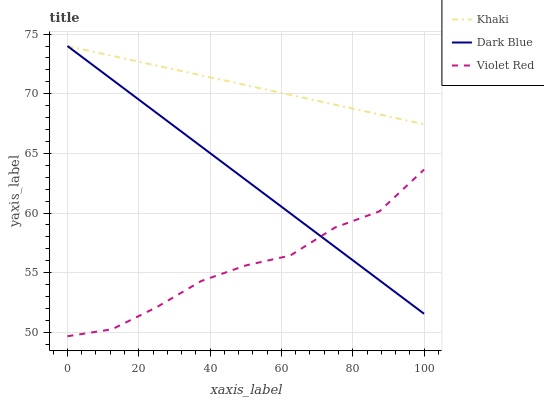Does Violet Red have the minimum area under the curve?
Answer yes or no. Yes. Does Khaki have the maximum area under the curve?
Answer yes or no. Yes. Does Khaki have the minimum area under the curve?
Answer yes or no. No. Does Violet Red have the maximum area under the curve?
Answer yes or no. No. Is Dark Blue the smoothest?
Answer yes or no. Yes. Is Violet Red the roughest?
Answer yes or no. Yes. Is Khaki the smoothest?
Answer yes or no. No. Is Khaki the roughest?
Answer yes or no. No. Does Violet Red have the lowest value?
Answer yes or no. Yes. Does Khaki have the lowest value?
Answer yes or no. No. Does Khaki have the highest value?
Answer yes or no. Yes. Does Violet Red have the highest value?
Answer yes or no. No. Is Violet Red less than Khaki?
Answer yes or no. Yes. Is Khaki greater than Violet Red?
Answer yes or no. Yes. Does Dark Blue intersect Violet Red?
Answer yes or no. Yes. Is Dark Blue less than Violet Red?
Answer yes or no. No. Is Dark Blue greater than Violet Red?
Answer yes or no. No. Does Violet Red intersect Khaki?
Answer yes or no. No. 